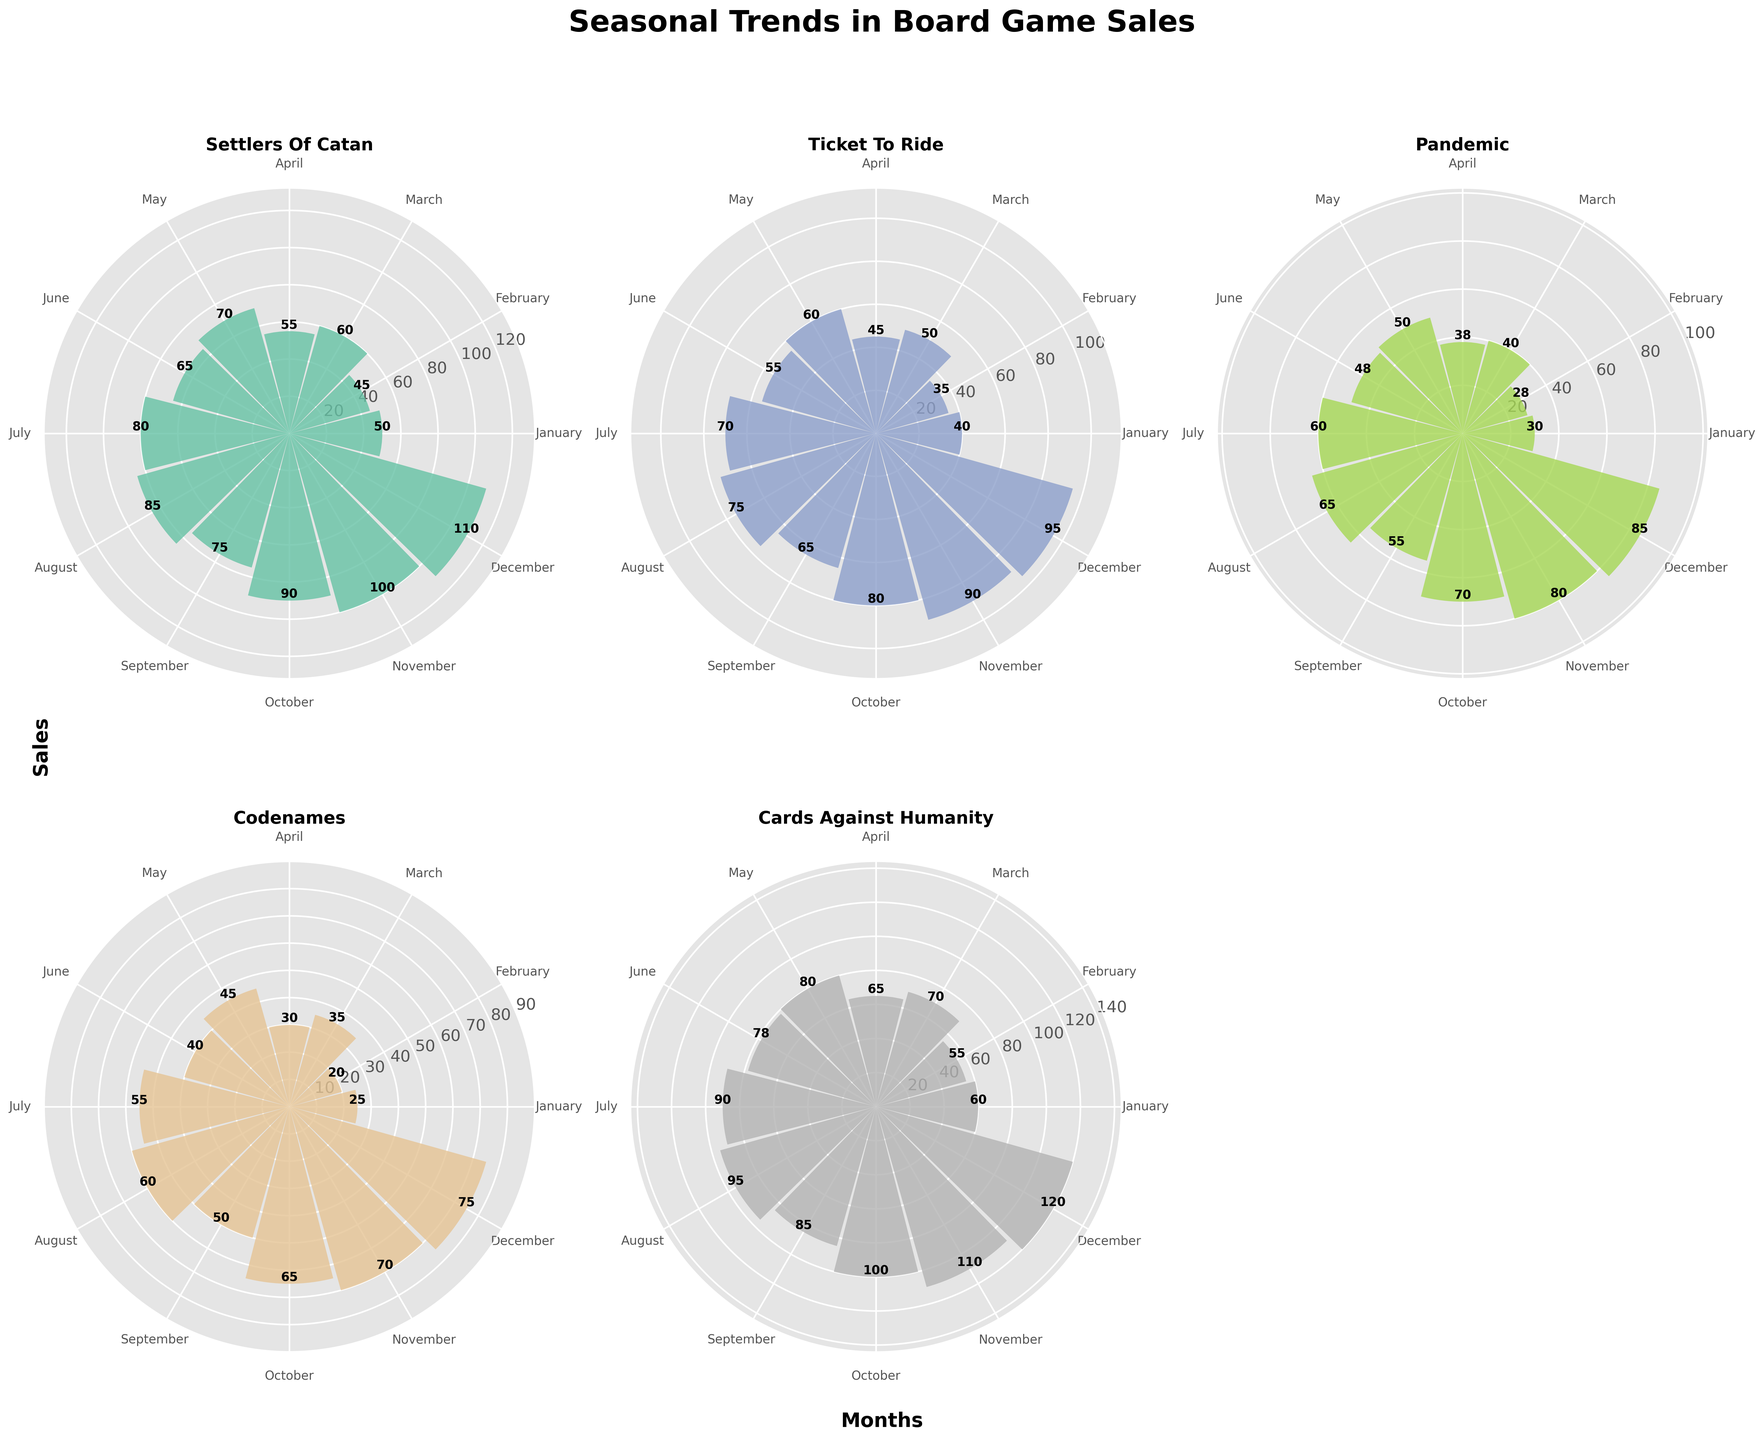What's the title of the figure? The title of the figure is placed prominently at the top center of the plot, clearly in bold and large font.
Answer: Seasonal Trends in Board Game Sales Which game has the highest sales in December? By looking at the subplot for December, observe which bar reaches the highest value. The "Cards Against Humanity" bar is the tallest for December.
Answer: Cards Against Humanity What are the sales numbers for "Codenames" in March and June? Refer to the subplot for "Codenames" and find the values corresponding to the labels for March and June. March shows 35 and June shows 40.
Answer: 35 for March, 40 for June How does the trend in sales for "Ticket to Ride" compare between July and October? Compare the bar heights for July and October in the "Ticket to Ride" subplot. July shows sales of 70, and October shows sales of 80.
Answer: July: 70, October: 80 What is the average sales number for "Pandemic" over the year? Sum the monthly sales values for "Pandemic" and divide by the number of months. (30+28+40+38+50+48+60+65+55+70+80+85) / 12 = 55.833
Answer: 55.83 Which month has the lowest sales for "Settlers of Catan"? Identify the smallest bar height in the "Settlers of Catan" subplot. January is the lowest with 50.
Answer: January Is there a month where the sales for "Codenames" surpass "Pandemic"? Compare the bar heights for all months between "Codenames" and "Pandemic". For every month, the sales of "Pandemic" are lower than "Codenames".
Answer: No Of all the games, which one shows the most uniform sales trend across all months? Identify the subplot where the bars are closest in height for all months. "Settlers of Catan" has a more uniform height throughout.
Answer: Settlers of Catan What's the total sales for "Cards Against Humanity" in the second half of the year (July-December)? Add the values from July to December for "Cards Against Humanity". 90 + 95 + 85 + 100 + 110 + 120 = 600
Answer: 600 By how much do the sales of "Settlers of Catan" in November exceed those in January? Subtract the sales value of January from November for "Settlers of Catan". 100 - 50 = 50
Answer: 50 